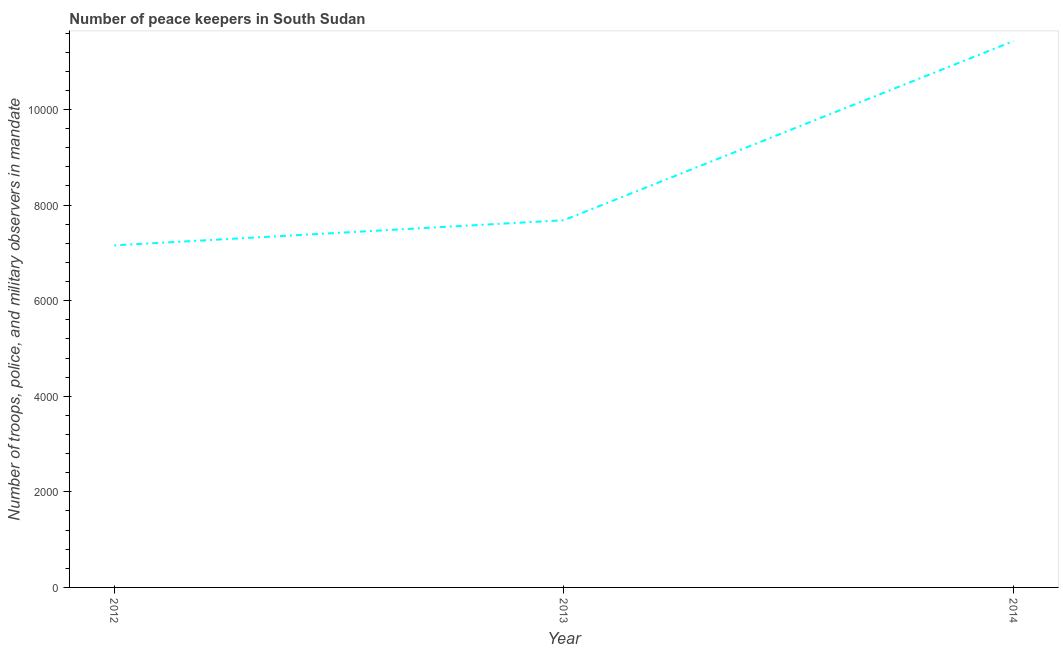What is the number of peace keepers in 2014?
Offer a very short reply. 1.14e+04. Across all years, what is the maximum number of peace keepers?
Provide a short and direct response. 1.14e+04. Across all years, what is the minimum number of peace keepers?
Your response must be concise. 7157. In which year was the number of peace keepers minimum?
Keep it short and to the point. 2012. What is the sum of the number of peace keepers?
Provide a short and direct response. 2.63e+04. What is the difference between the number of peace keepers in 2012 and 2014?
Your answer should be compact. -4276. What is the average number of peace keepers per year?
Give a very brief answer. 8758. What is the median number of peace keepers?
Provide a succinct answer. 7684. Do a majority of the years between 2013 and 2012 (inclusive) have number of peace keepers greater than 4800 ?
Your answer should be very brief. No. What is the ratio of the number of peace keepers in 2012 to that in 2014?
Offer a terse response. 0.63. What is the difference between the highest and the second highest number of peace keepers?
Your answer should be very brief. 3749. What is the difference between the highest and the lowest number of peace keepers?
Provide a short and direct response. 4276. In how many years, is the number of peace keepers greater than the average number of peace keepers taken over all years?
Offer a terse response. 1. How many lines are there?
Provide a short and direct response. 1. How many years are there in the graph?
Give a very brief answer. 3. Does the graph contain grids?
Ensure brevity in your answer.  No. What is the title of the graph?
Your response must be concise. Number of peace keepers in South Sudan. What is the label or title of the Y-axis?
Your answer should be compact. Number of troops, police, and military observers in mandate. What is the Number of troops, police, and military observers in mandate in 2012?
Provide a short and direct response. 7157. What is the Number of troops, police, and military observers in mandate in 2013?
Your answer should be compact. 7684. What is the Number of troops, police, and military observers in mandate in 2014?
Provide a succinct answer. 1.14e+04. What is the difference between the Number of troops, police, and military observers in mandate in 2012 and 2013?
Make the answer very short. -527. What is the difference between the Number of troops, police, and military observers in mandate in 2012 and 2014?
Make the answer very short. -4276. What is the difference between the Number of troops, police, and military observers in mandate in 2013 and 2014?
Offer a very short reply. -3749. What is the ratio of the Number of troops, police, and military observers in mandate in 2012 to that in 2014?
Make the answer very short. 0.63. What is the ratio of the Number of troops, police, and military observers in mandate in 2013 to that in 2014?
Offer a terse response. 0.67. 